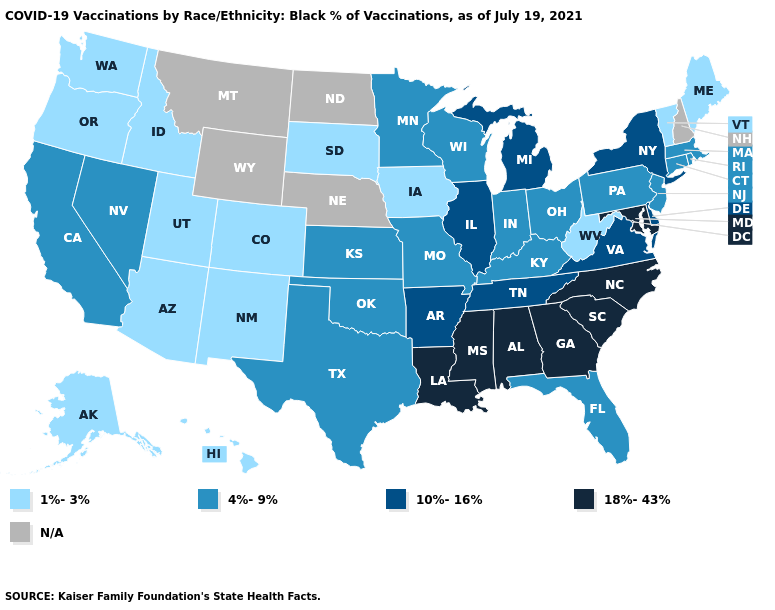Does Michigan have the lowest value in the USA?
Short answer required. No. Name the states that have a value in the range N/A?
Be succinct. Montana, Nebraska, New Hampshire, North Dakota, Wyoming. Does Iowa have the highest value in the USA?
Short answer required. No. Does South Carolina have the highest value in the USA?
Give a very brief answer. Yes. Is the legend a continuous bar?
Keep it brief. No. What is the lowest value in states that border Colorado?
Answer briefly. 1%-3%. Which states have the lowest value in the MidWest?
Answer briefly. Iowa, South Dakota. Name the states that have a value in the range 18%-43%?
Quick response, please. Alabama, Georgia, Louisiana, Maryland, Mississippi, North Carolina, South Carolina. Name the states that have a value in the range 4%-9%?
Short answer required. California, Connecticut, Florida, Indiana, Kansas, Kentucky, Massachusetts, Minnesota, Missouri, Nevada, New Jersey, Ohio, Oklahoma, Pennsylvania, Rhode Island, Texas, Wisconsin. Name the states that have a value in the range 1%-3%?
Write a very short answer. Alaska, Arizona, Colorado, Hawaii, Idaho, Iowa, Maine, New Mexico, Oregon, South Dakota, Utah, Vermont, Washington, West Virginia. How many symbols are there in the legend?
Quick response, please. 5. Name the states that have a value in the range 1%-3%?
Write a very short answer. Alaska, Arizona, Colorado, Hawaii, Idaho, Iowa, Maine, New Mexico, Oregon, South Dakota, Utah, Vermont, Washington, West Virginia. Does the map have missing data?
Short answer required. Yes. Name the states that have a value in the range 18%-43%?
Quick response, please. Alabama, Georgia, Louisiana, Maryland, Mississippi, North Carolina, South Carolina. What is the value of Michigan?
Quick response, please. 10%-16%. 